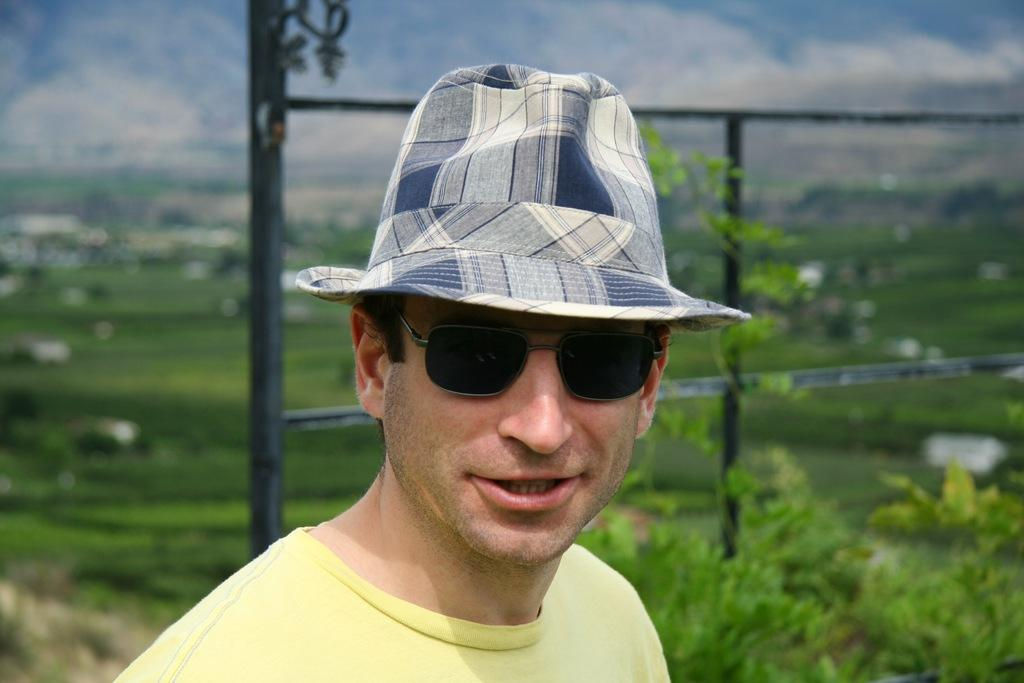What is the main subject of the image? There is a man in the image. Can you describe the man's clothing? The man is wearing a yellow t-shirt. What accessories is the man wearing? The man is wearing spectacles and a hat. What can be seen behind the man? There are iron rods and plants behind the man. What is visible in the background of the image? The sky is visible in the background of the image. What type of good-bye message is the man holding in the image? There is no good-bye message present in the image. Is the man part of an army in the image? There is no indication in the image that the man is part of an army. 